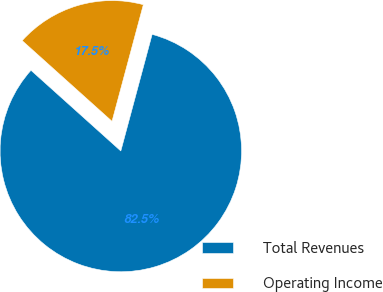<chart> <loc_0><loc_0><loc_500><loc_500><pie_chart><fcel>Total Revenues<fcel>Operating Income<nl><fcel>82.47%<fcel>17.53%<nl></chart> 